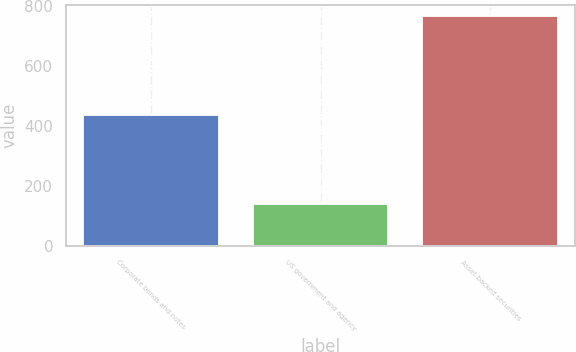Convert chart. <chart><loc_0><loc_0><loc_500><loc_500><bar_chart><fcel>Corporate bonds and notes<fcel>US government and agency<fcel>Asset-backed securities<nl><fcel>437<fcel>139<fcel>766<nl></chart> 